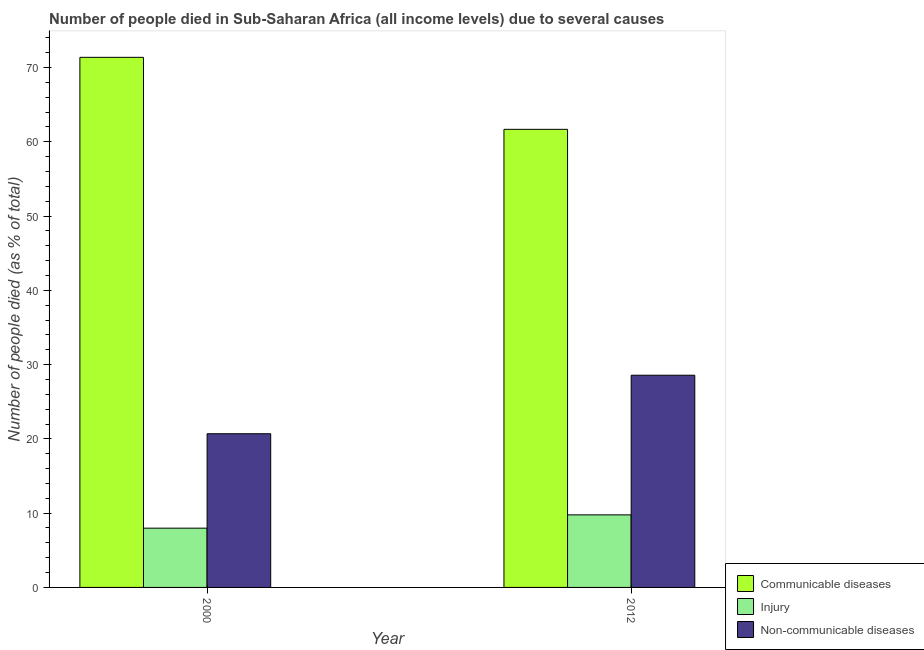How many different coloured bars are there?
Make the answer very short. 3. How many groups of bars are there?
Provide a succinct answer. 2. Are the number of bars per tick equal to the number of legend labels?
Provide a short and direct response. Yes. In how many cases, is the number of bars for a given year not equal to the number of legend labels?
Provide a succinct answer. 0. What is the number of people who dies of non-communicable diseases in 2012?
Make the answer very short. 28.56. Across all years, what is the maximum number of people who dies of non-communicable diseases?
Your response must be concise. 28.56. Across all years, what is the minimum number of people who died of communicable diseases?
Give a very brief answer. 61.67. What is the total number of people who died of communicable diseases in the graph?
Offer a very short reply. 133.03. What is the difference between the number of people who died of communicable diseases in 2000 and that in 2012?
Provide a short and direct response. 9.69. What is the difference between the number of people who died of communicable diseases in 2000 and the number of people who dies of non-communicable diseases in 2012?
Offer a very short reply. 9.69. What is the average number of people who died of communicable diseases per year?
Provide a succinct answer. 66.51. In how many years, is the number of people who dies of non-communicable diseases greater than 40 %?
Your answer should be compact. 0. What is the ratio of the number of people who died of injury in 2000 to that in 2012?
Offer a terse response. 0.82. Is the number of people who dies of non-communicable diseases in 2000 less than that in 2012?
Keep it short and to the point. Yes. What does the 2nd bar from the left in 2012 represents?
Keep it short and to the point. Injury. What does the 1st bar from the right in 2012 represents?
Provide a short and direct response. Non-communicable diseases. Is it the case that in every year, the sum of the number of people who died of communicable diseases and number of people who died of injury is greater than the number of people who dies of non-communicable diseases?
Make the answer very short. Yes. Are all the bars in the graph horizontal?
Make the answer very short. No. How many years are there in the graph?
Your answer should be compact. 2. Does the graph contain any zero values?
Keep it short and to the point. No. Does the graph contain grids?
Ensure brevity in your answer.  No. How many legend labels are there?
Make the answer very short. 3. What is the title of the graph?
Offer a terse response. Number of people died in Sub-Saharan Africa (all income levels) due to several causes. What is the label or title of the Y-axis?
Provide a short and direct response. Number of people died (as % of total). What is the Number of people died (as % of total) of Communicable diseases in 2000?
Provide a succinct answer. 71.36. What is the Number of people died (as % of total) of Injury in 2000?
Provide a succinct answer. 7.98. What is the Number of people died (as % of total) of Non-communicable diseases in 2000?
Ensure brevity in your answer.  20.69. What is the Number of people died (as % of total) in Communicable diseases in 2012?
Your response must be concise. 61.67. What is the Number of people died (as % of total) of Injury in 2012?
Give a very brief answer. 9.77. What is the Number of people died (as % of total) of Non-communicable diseases in 2012?
Your answer should be very brief. 28.56. Across all years, what is the maximum Number of people died (as % of total) in Communicable diseases?
Provide a succinct answer. 71.36. Across all years, what is the maximum Number of people died (as % of total) in Injury?
Ensure brevity in your answer.  9.77. Across all years, what is the maximum Number of people died (as % of total) of Non-communicable diseases?
Your answer should be very brief. 28.56. Across all years, what is the minimum Number of people died (as % of total) of Communicable diseases?
Give a very brief answer. 61.67. Across all years, what is the minimum Number of people died (as % of total) of Injury?
Offer a terse response. 7.98. Across all years, what is the minimum Number of people died (as % of total) of Non-communicable diseases?
Give a very brief answer. 20.69. What is the total Number of people died (as % of total) in Communicable diseases in the graph?
Provide a succinct answer. 133.03. What is the total Number of people died (as % of total) of Injury in the graph?
Provide a succinct answer. 17.74. What is the total Number of people died (as % of total) of Non-communicable diseases in the graph?
Offer a terse response. 49.25. What is the difference between the Number of people died (as % of total) of Communicable diseases in 2000 and that in 2012?
Ensure brevity in your answer.  9.69. What is the difference between the Number of people died (as % of total) of Injury in 2000 and that in 2012?
Make the answer very short. -1.79. What is the difference between the Number of people died (as % of total) in Non-communicable diseases in 2000 and that in 2012?
Offer a very short reply. -7.88. What is the difference between the Number of people died (as % of total) of Communicable diseases in 2000 and the Number of people died (as % of total) of Injury in 2012?
Keep it short and to the point. 61.59. What is the difference between the Number of people died (as % of total) in Communicable diseases in 2000 and the Number of people died (as % of total) in Non-communicable diseases in 2012?
Your response must be concise. 42.8. What is the difference between the Number of people died (as % of total) in Injury in 2000 and the Number of people died (as % of total) in Non-communicable diseases in 2012?
Provide a succinct answer. -20.59. What is the average Number of people died (as % of total) of Communicable diseases per year?
Your answer should be very brief. 66.51. What is the average Number of people died (as % of total) of Injury per year?
Give a very brief answer. 8.87. What is the average Number of people died (as % of total) in Non-communicable diseases per year?
Offer a terse response. 24.63. In the year 2000, what is the difference between the Number of people died (as % of total) of Communicable diseases and Number of people died (as % of total) of Injury?
Make the answer very short. 63.38. In the year 2000, what is the difference between the Number of people died (as % of total) of Communicable diseases and Number of people died (as % of total) of Non-communicable diseases?
Provide a short and direct response. 50.67. In the year 2000, what is the difference between the Number of people died (as % of total) in Injury and Number of people died (as % of total) in Non-communicable diseases?
Offer a terse response. -12.71. In the year 2012, what is the difference between the Number of people died (as % of total) of Communicable diseases and Number of people died (as % of total) of Injury?
Provide a succinct answer. 51.9. In the year 2012, what is the difference between the Number of people died (as % of total) in Communicable diseases and Number of people died (as % of total) in Non-communicable diseases?
Offer a very short reply. 33.1. In the year 2012, what is the difference between the Number of people died (as % of total) of Injury and Number of people died (as % of total) of Non-communicable diseases?
Your answer should be very brief. -18.8. What is the ratio of the Number of people died (as % of total) in Communicable diseases in 2000 to that in 2012?
Keep it short and to the point. 1.16. What is the ratio of the Number of people died (as % of total) in Injury in 2000 to that in 2012?
Your response must be concise. 0.82. What is the ratio of the Number of people died (as % of total) of Non-communicable diseases in 2000 to that in 2012?
Ensure brevity in your answer.  0.72. What is the difference between the highest and the second highest Number of people died (as % of total) in Communicable diseases?
Make the answer very short. 9.69. What is the difference between the highest and the second highest Number of people died (as % of total) in Injury?
Ensure brevity in your answer.  1.79. What is the difference between the highest and the second highest Number of people died (as % of total) in Non-communicable diseases?
Provide a short and direct response. 7.88. What is the difference between the highest and the lowest Number of people died (as % of total) of Communicable diseases?
Give a very brief answer. 9.69. What is the difference between the highest and the lowest Number of people died (as % of total) in Injury?
Offer a very short reply. 1.79. What is the difference between the highest and the lowest Number of people died (as % of total) in Non-communicable diseases?
Your response must be concise. 7.88. 